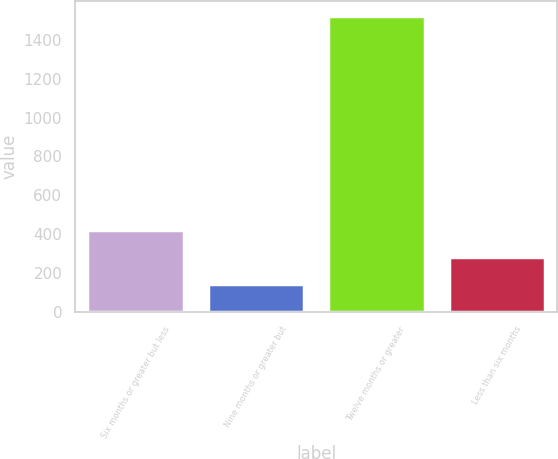<chart> <loc_0><loc_0><loc_500><loc_500><bar_chart><fcel>Six months or greater but less<fcel>Nine months or greater but<fcel>Twelve months or greater<fcel>Less than six months<nl><fcel>419<fcel>143<fcel>1523<fcel>281<nl></chart> 